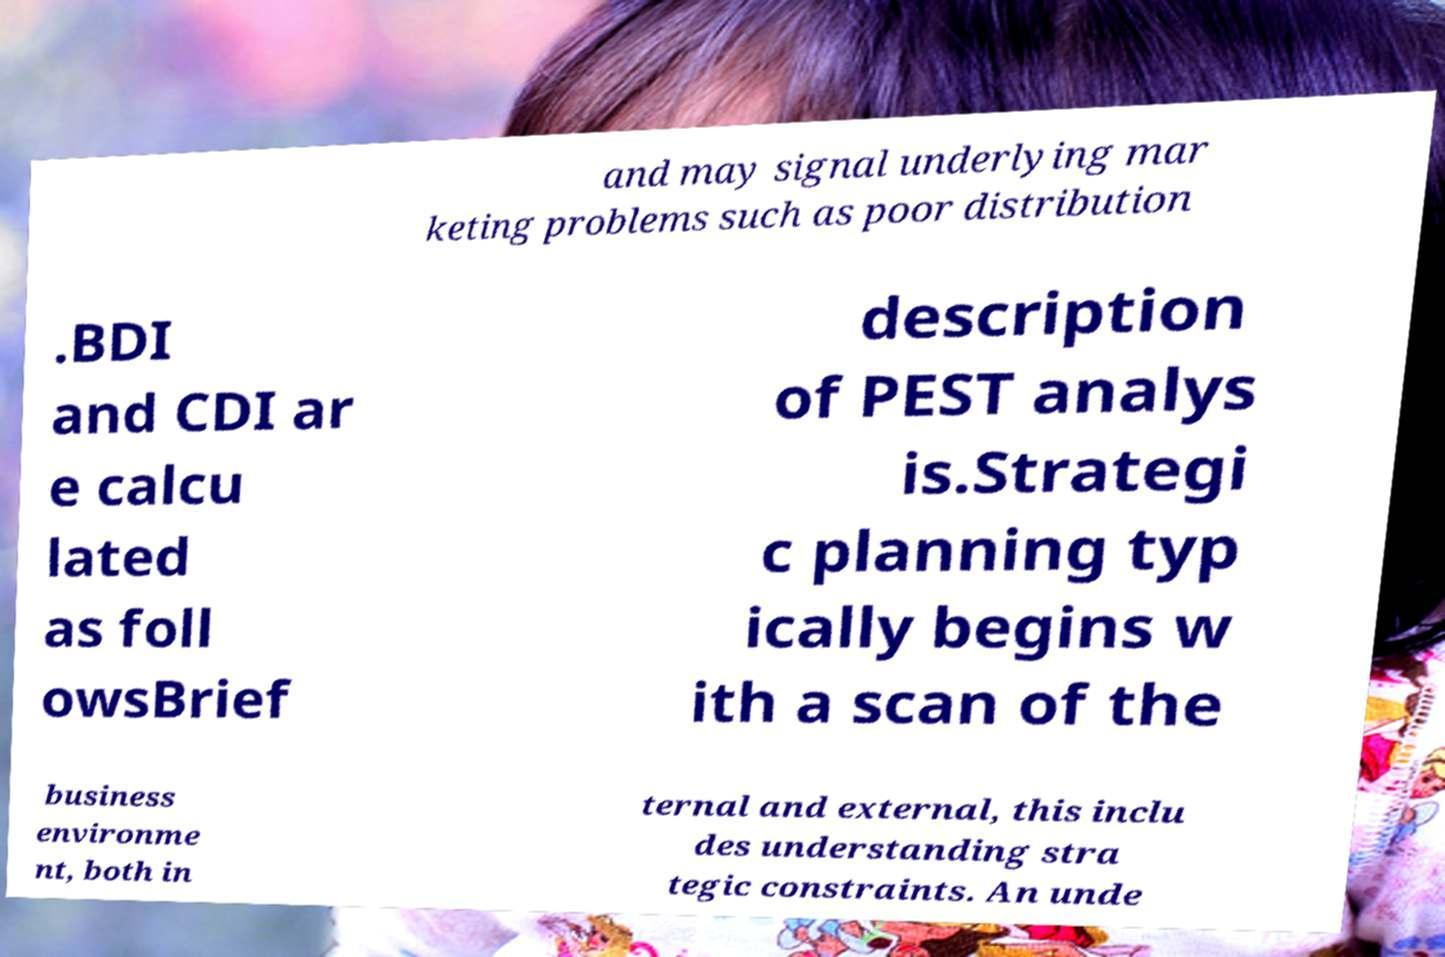Can you read and provide the text displayed in the image?This photo seems to have some interesting text. Can you extract and type it out for me? and may signal underlying mar keting problems such as poor distribution .BDI and CDI ar e calcu lated as foll owsBrief description of PEST analys is.Strategi c planning typ ically begins w ith a scan of the business environme nt, both in ternal and external, this inclu des understanding stra tegic constraints. An unde 